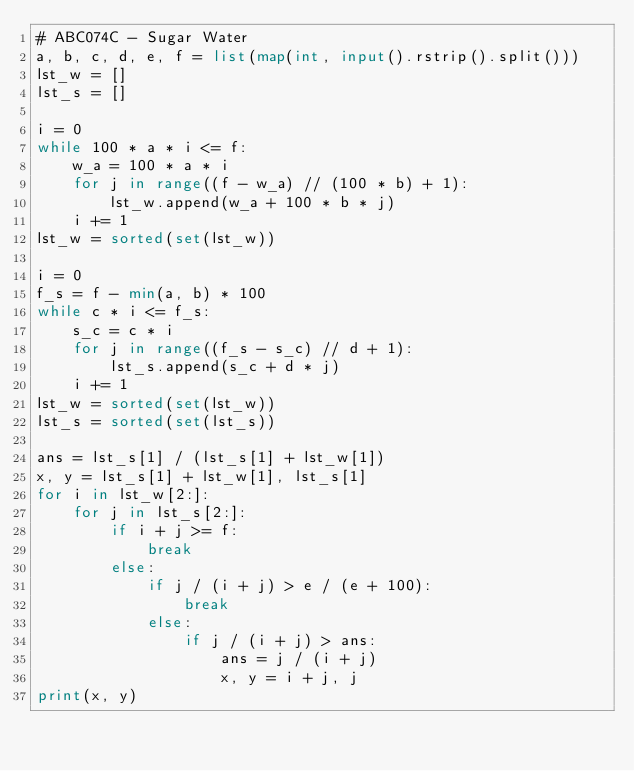Convert code to text. <code><loc_0><loc_0><loc_500><loc_500><_Python_># ABC074C - Sugar Water
a, b, c, d, e, f = list(map(int, input().rstrip().split()))
lst_w = []
lst_s = []

i = 0
while 100 * a * i <= f:
    w_a = 100 * a * i
    for j in range((f - w_a) // (100 * b) + 1):
        lst_w.append(w_a + 100 * b * j)
    i += 1
lst_w = sorted(set(lst_w))

i = 0
f_s = f - min(a, b) * 100
while c * i <= f_s:
    s_c = c * i
    for j in range((f_s - s_c) // d + 1):
        lst_s.append(s_c + d * j)
    i += 1
lst_w = sorted(set(lst_w))
lst_s = sorted(set(lst_s))

ans = lst_s[1] / (lst_s[1] + lst_w[1])
x, y = lst_s[1] + lst_w[1], lst_s[1]
for i in lst_w[2:]:
    for j in lst_s[2:]:
        if i + j >= f:
            break
        else:
            if j / (i + j) > e / (e + 100):
                break
            else:
                if j / (i + j) > ans:
                    ans = j / (i + j)
                    x, y = i + j, j
print(x, y)</code> 